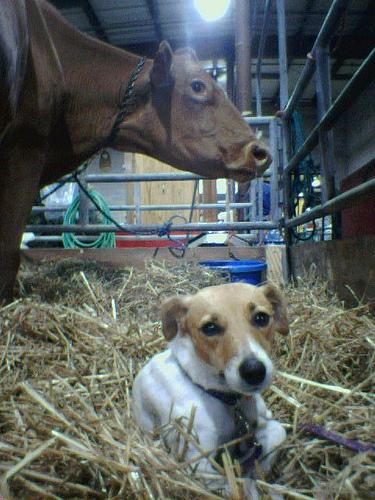What kind of dog is this?
Answer briefly. Beagle. What is the dog laying on?
Quick response, please. Hay. Can you get milk from both of these animals?
Answer briefly. No. 